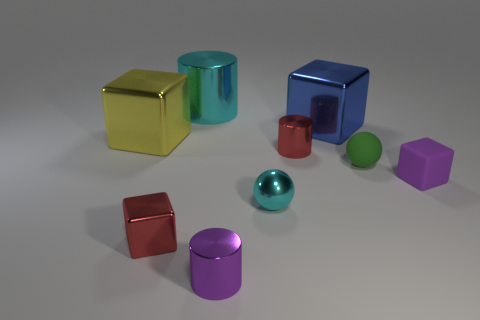Subtract all cyan cubes. Subtract all cyan cylinders. How many cubes are left? 4 Subtract all cylinders. How many objects are left? 6 Subtract all cyan metallic objects. Subtract all large cylinders. How many objects are left? 6 Add 7 tiny red objects. How many tiny red objects are left? 9 Add 5 tiny green objects. How many tiny green objects exist? 6 Subtract 1 purple cylinders. How many objects are left? 8 